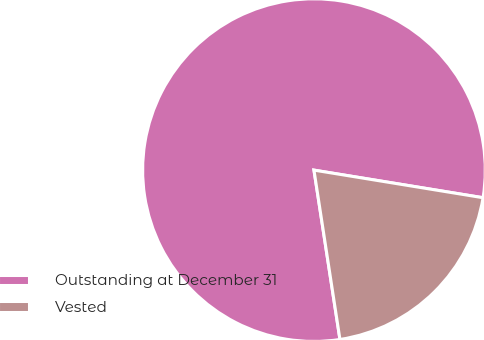Convert chart to OTSL. <chart><loc_0><loc_0><loc_500><loc_500><pie_chart><fcel>Outstanding at December 31<fcel>Vested<nl><fcel>80.0%<fcel>20.0%<nl></chart> 